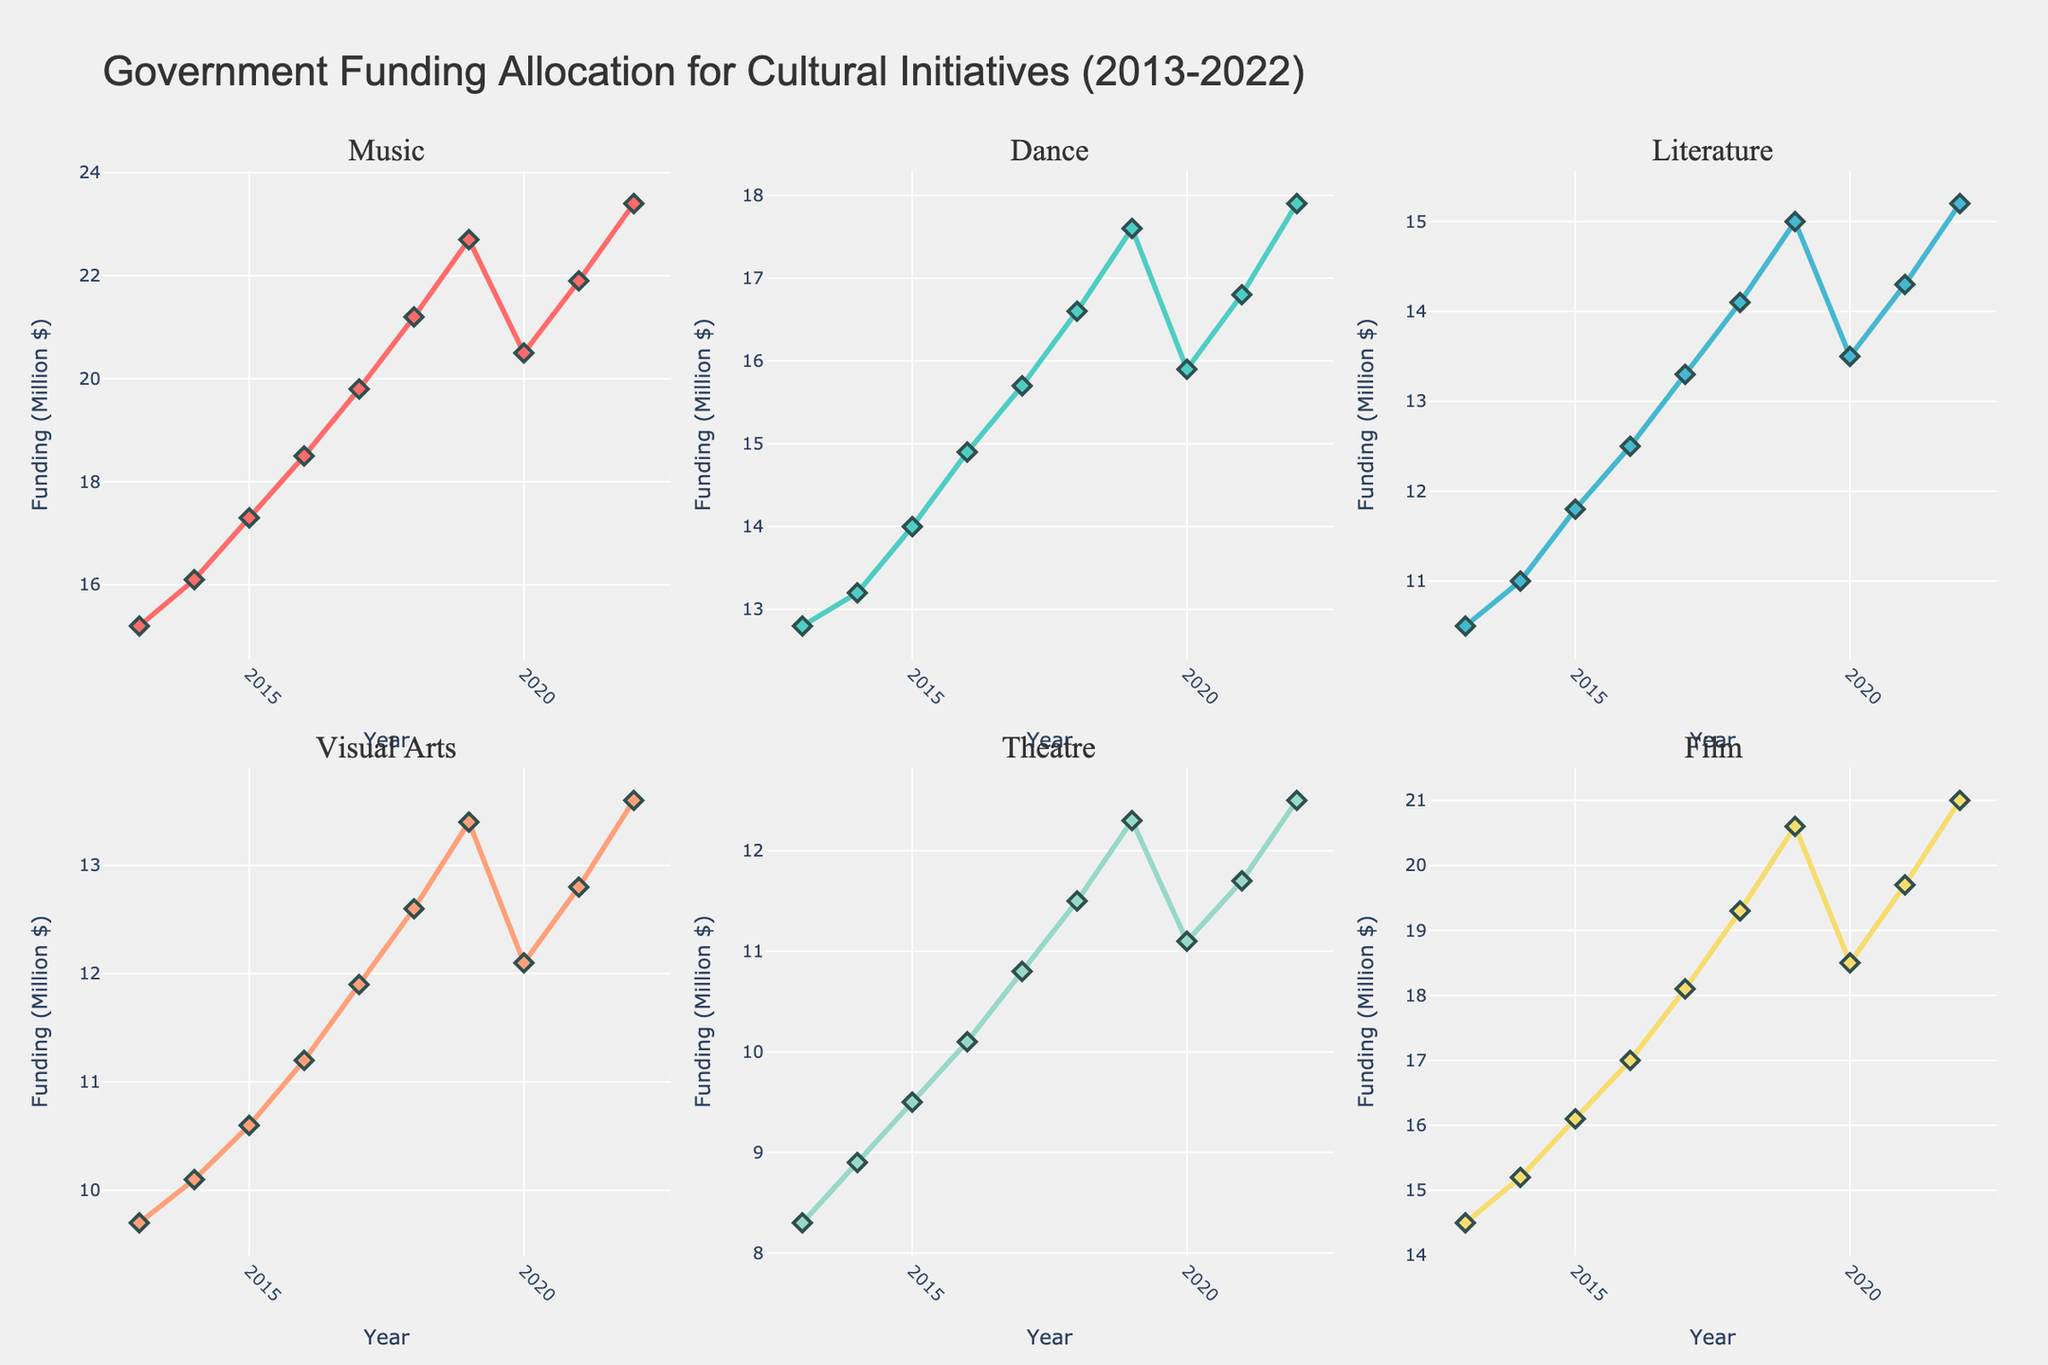What is the title of the figure? The title of the figure is usually displayed at the top in larger font size.
Answer: Government Funding Allocation for Cultural Initiatives (2013-2022) What are the sectors shown in the figure? The sectors are the subplot titles. The titles can be seen at the top of each subplot.
Answer: Music, Dance, Literature, Visual Arts, Theatre, Film Which sector received the highest funding in 2022? Locate the end point for each sector in 2022 and compare the values. Music is at the highest point among all subplots.
Answer: Music What is the trend of funding for Dance from 2013 to 2022? Observe the line graph for Dance from 2013 to 2022. The line shows a general upward trend with small fluctuations.
Answer: Upward trend What was the funding for Theatre in 2018? Check the point corresponding to the year 2018 on the Theatre subplot. The y-axis value at that point is the required answer.
Answer: 11.5 Million $ How did the funding for Film change from 2019 to 2020? Inspect the Film subplot and find the y-values for the years 2019 and 2020. Subtract the 2020 value from the 2019 value to see the change.
Answer: Decreased by 2.1 Million $ Between which two years did Music see the largest increase in funding? Examine the Music subplot and look for two consecutive years with the largest vertical distance between points. The largest increase is between 2018 and 2019.
Answer: 2018 and 2019 What is the average funding for Visual Arts over the decade? To find the average, sum the funding amounts for Visual Arts from 2013 to 2022 and divide by the number of years (10).
Answer: 11.3 Million $ Which sector showed a decrease in funding in 2020? Check all subplots for the year 2020 and identify if the point is lower compared to 2019. Dance, Literature, Visual Arts, Theatre, and Film all showed a decrease.
Answer: Dance, Literature, Visual Arts, Theatre, Film What is the total funding allocated to Music over the 10-year period? Add up all the funding values for Music from 2013 to 2022.
Answer: 196.6 Million $ 